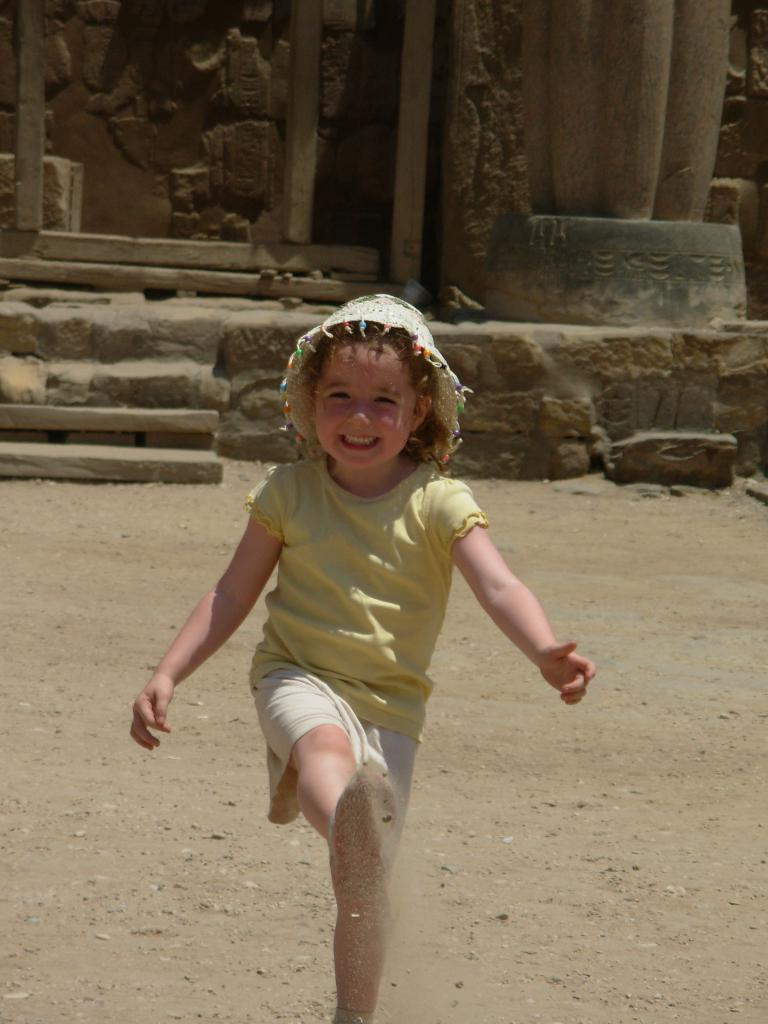Who is the main subject in the foreground of the image? There is a girl in the foreground of the image. What is the girl doing in the image? The girl is standing and smiling. What can be seen in the background of the image? There are sculptures, a wall, and stairs in the background of the image. What is the ground made of in the image? There is sand at the bottom of the image. What type of glue is being used to create harmony between the feathers in the image? There are no feathers or glue present in the image. 